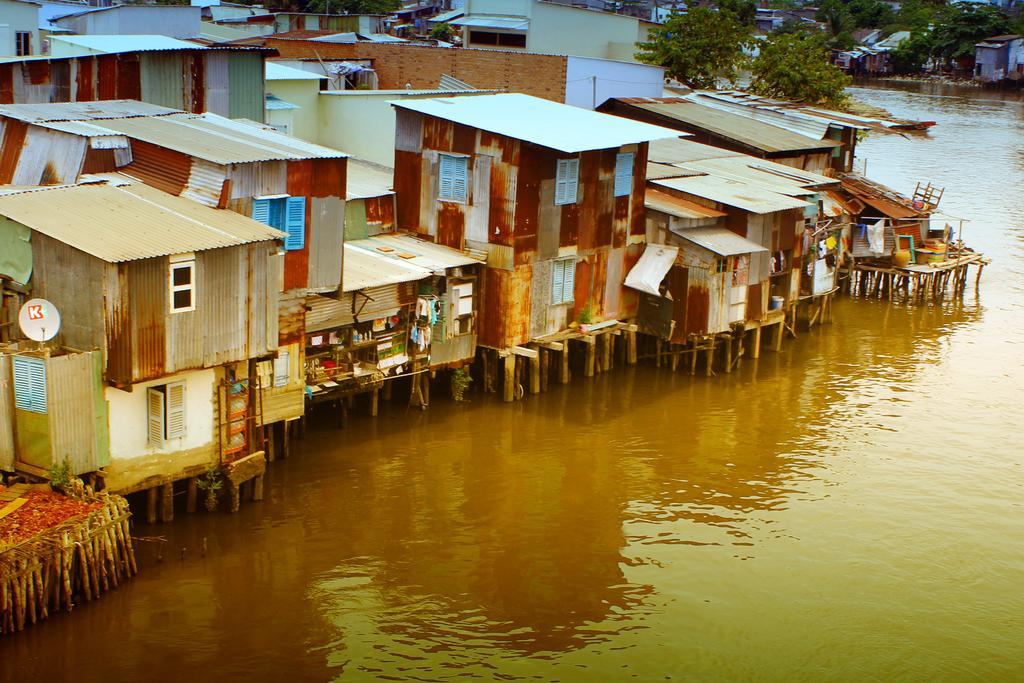How would you summarize this image in a sentence or two? In this image on the right side, I can see the water. In the background, I can see the buildings and the trees. 